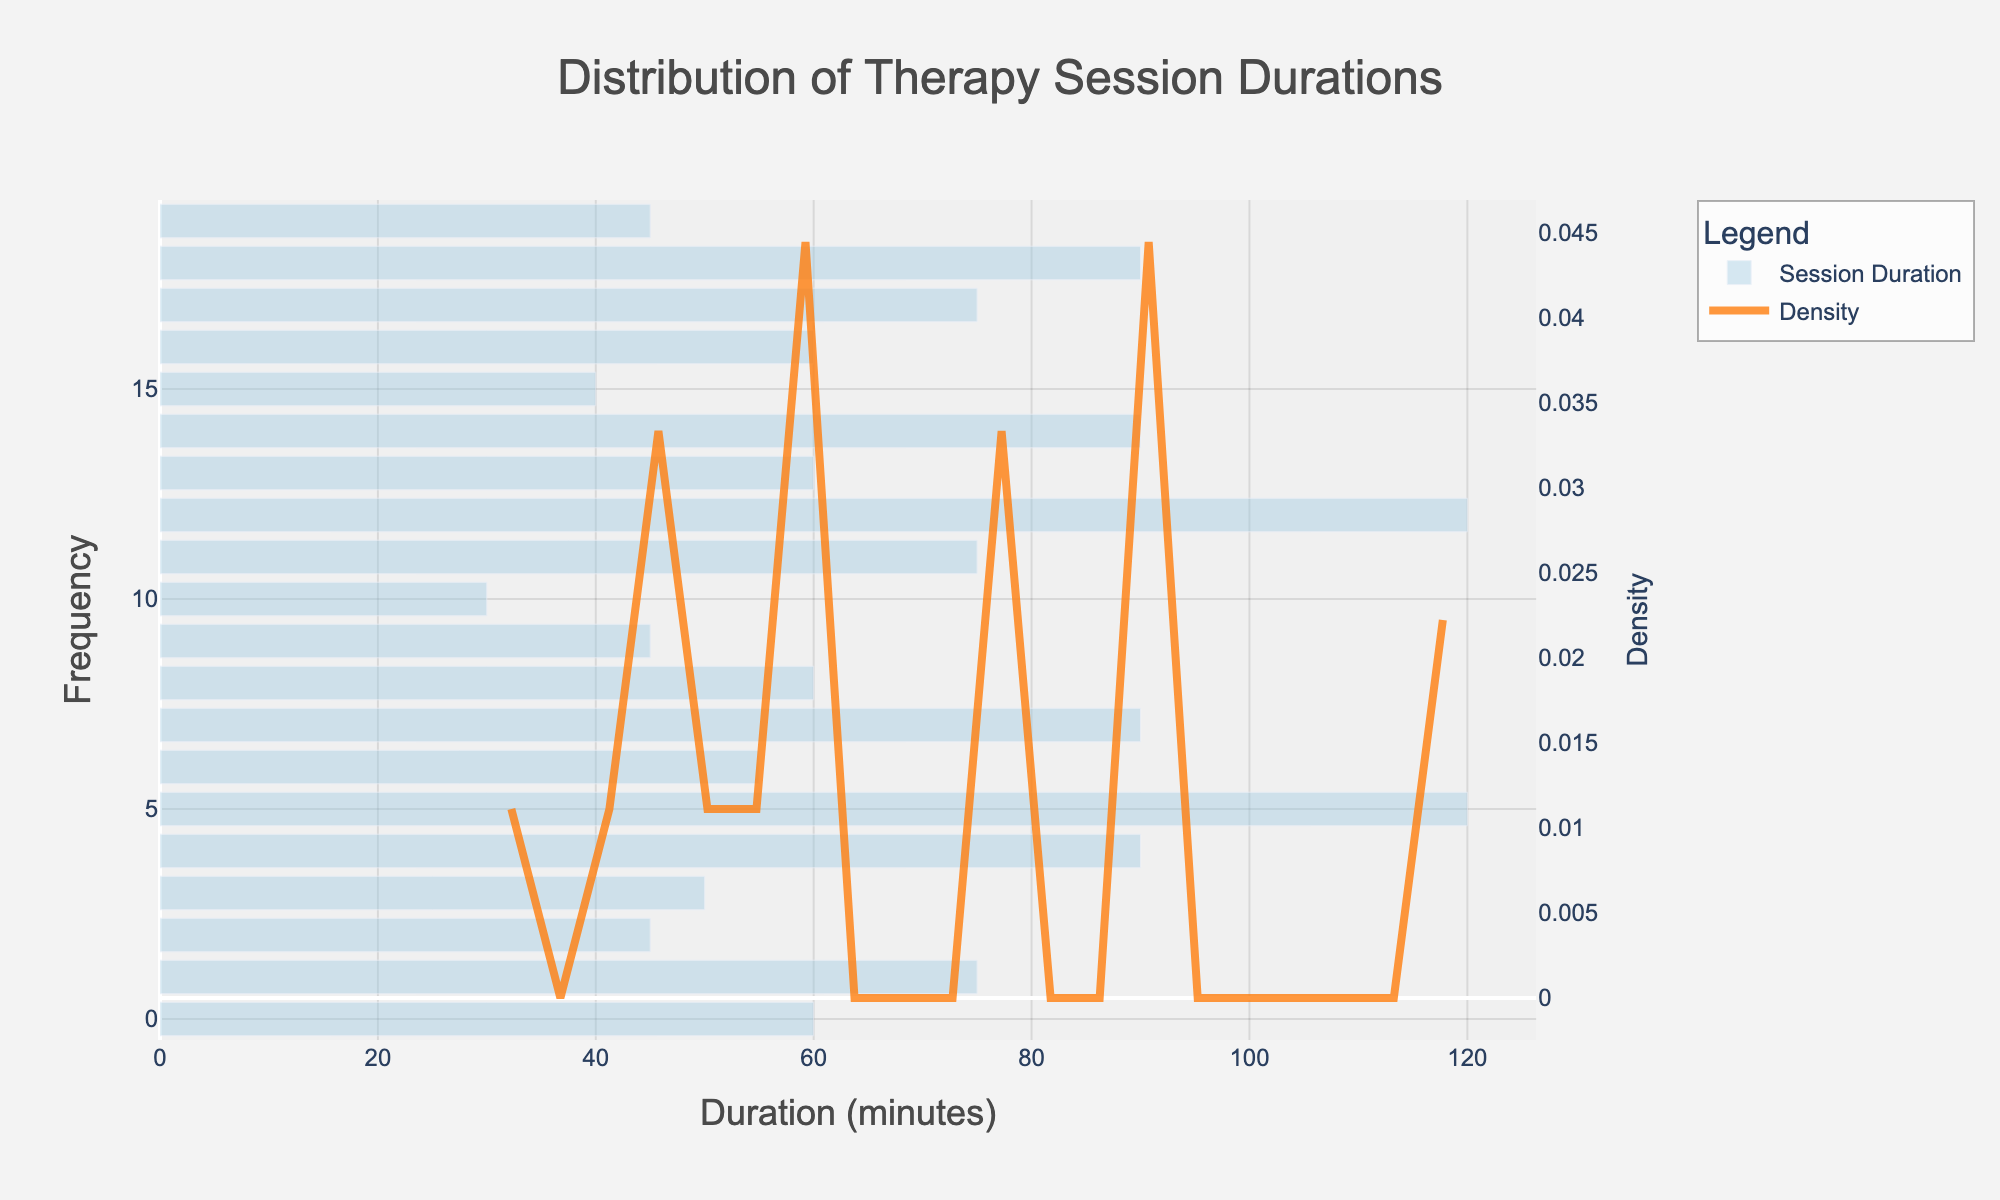what is the title of the figure? The title is displayed at the top of the figure and provides a description of what the figure represents. The title is "Distribution of Therapy Session Durations".
Answer: Distribution of Therapy Session Durations What is the x-axis representing? The x-axis label is indicated underneath the x-axis. It represents the duration of the therapy sessions in minutes.
Answer: Duration (minutes) What color represents the session durations in the histogram? The histogram bars are displayed in a light blue color, implying session durations.
Answer: light blue Which therapy modality has the longest average duration? The figure shows that Yoga Therapy and Thai Massage have the longest durations, both at 120 minutes.
Answer: Yoga Therapy and Thai Massage How many therapy modalities have durations between 40 and 60 minutes? By observing the histogram bars that correspond to the 40-60 minute range, we see that there are Flower Essence Therapy (40), Aromatherapy (45), Herbal Medicine Consultation (45), Crystal Healing (50), Reflexology (55), and Chakra Balancing (60).
Answer: 6 What is the most common session duration range? The KDE (density curve) shows the highest peak, representing the most common session durations. This peak appears around 60 minutes.
Answer: Around 60 minutes Is the density of therapy sessions uniformly distributed across the different durations? By analyzing the KDE curve, we notice peaks and troughs, indicating that the density is not uniformly distributed. Some durations are more common than others.
Answer: No Which session duration range has the lowest density? The KDE curve has its lowest points, indicating the least common durations. This occurs around the 30-minute mark.
Answer: Around 30 minutes What is the approximate frequency of 90-minute sessions? The height of the histogram bar at the 90-minute mark represents the frequency of the 90-minute sessions. There are a few bars at this duration level, suggesting it is moderately frequent.
Answer: Moderate frequency 